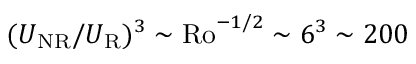Convert formula to latex. <formula><loc_0><loc_0><loc_500><loc_500>( U _ { N R } / U _ { R } ) ^ { 3 } \sim R o ^ { - 1 / 2 } \sim 6 ^ { 3 } \sim 2 0 0</formula> 